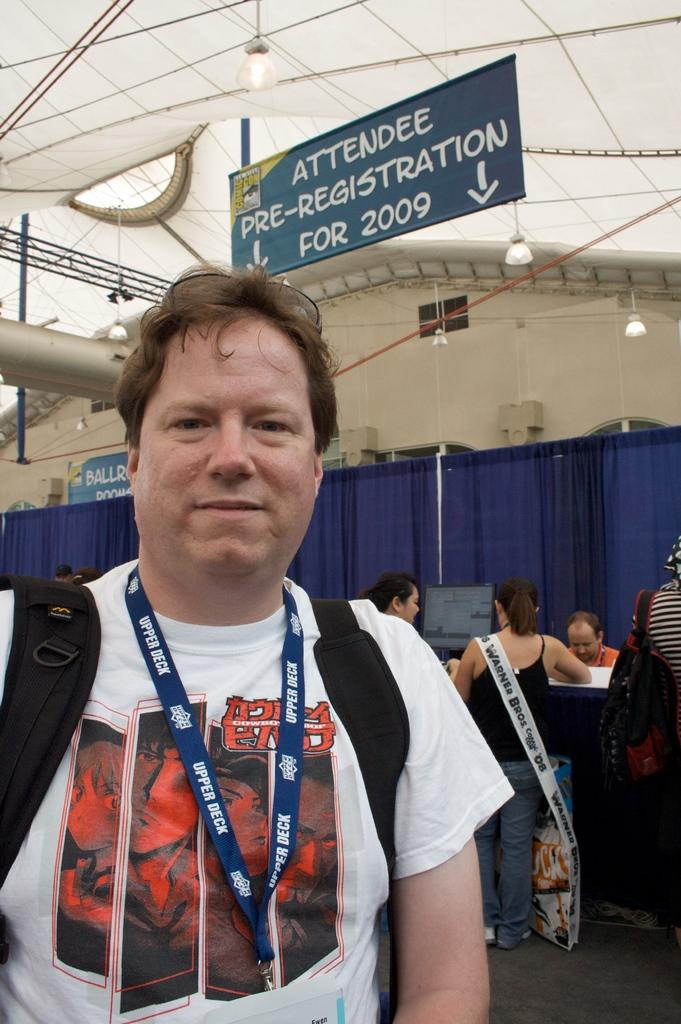<image>
Provide a brief description of the given image. Man standing near the attendee pre-registration booth in 2009 